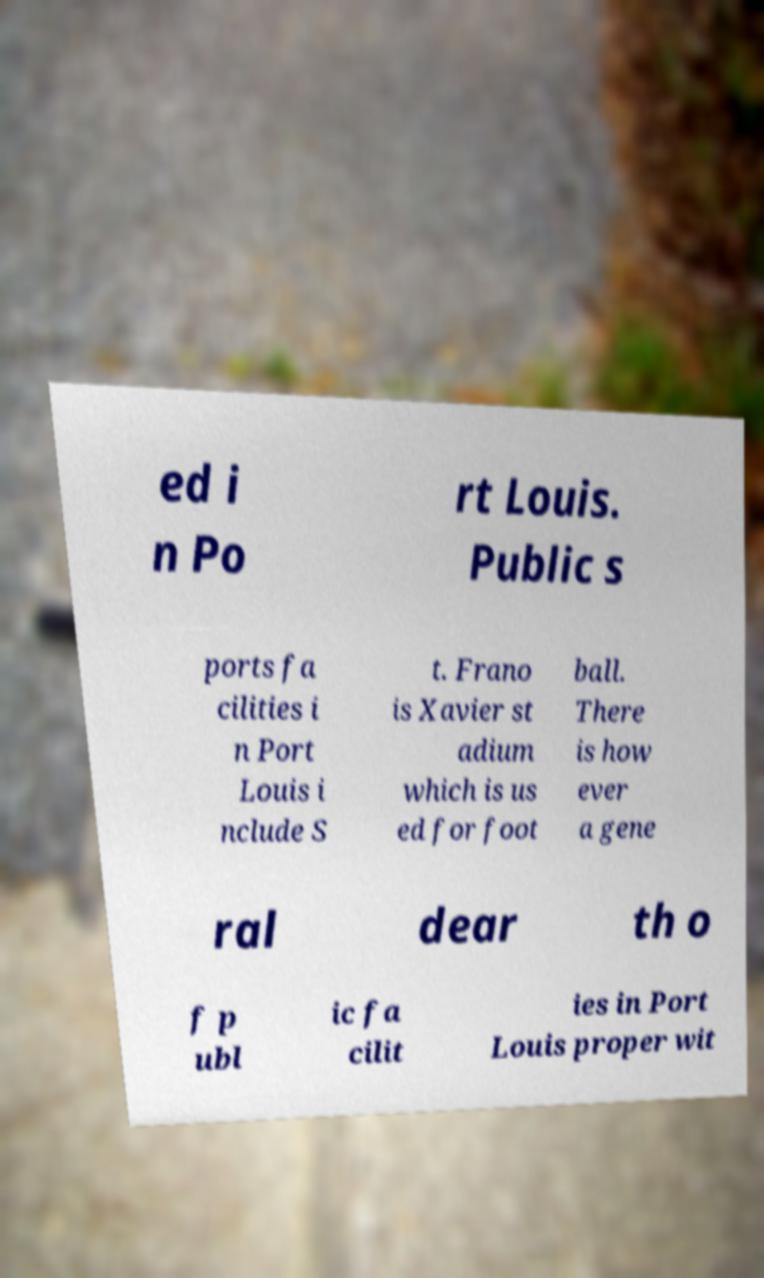Please read and relay the text visible in this image. What does it say? ed i n Po rt Louis. Public s ports fa cilities i n Port Louis i nclude S t. Frano is Xavier st adium which is us ed for foot ball. There is how ever a gene ral dear th o f p ubl ic fa cilit ies in Port Louis proper wit 